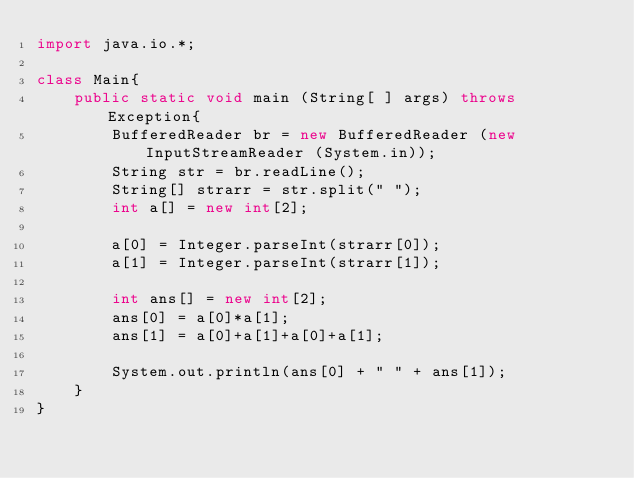Convert code to text. <code><loc_0><loc_0><loc_500><loc_500><_Java_>import java.io.*;
 
class Main{
    public static void main (String[ ] args) throws Exception{
        BufferedReader br = new BufferedReader (new InputStreamReader (System.in));
        String str = br.readLine();
        String[] strarr = str.split(" ");
        int a[] = new int[2];

        a[0] = Integer.parseInt(strarr[0]);
        a[1] = Integer.parseInt(strarr[1]);
        
        int ans[] = new int[2];
        ans[0] = a[0]*a[1];
        ans[1] = a[0]+a[1]+a[0]+a[1];
        
        System.out.println(ans[0] + " " + ans[1]);
    }
}</code> 